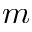<formula> <loc_0><loc_0><loc_500><loc_500>m</formula> 